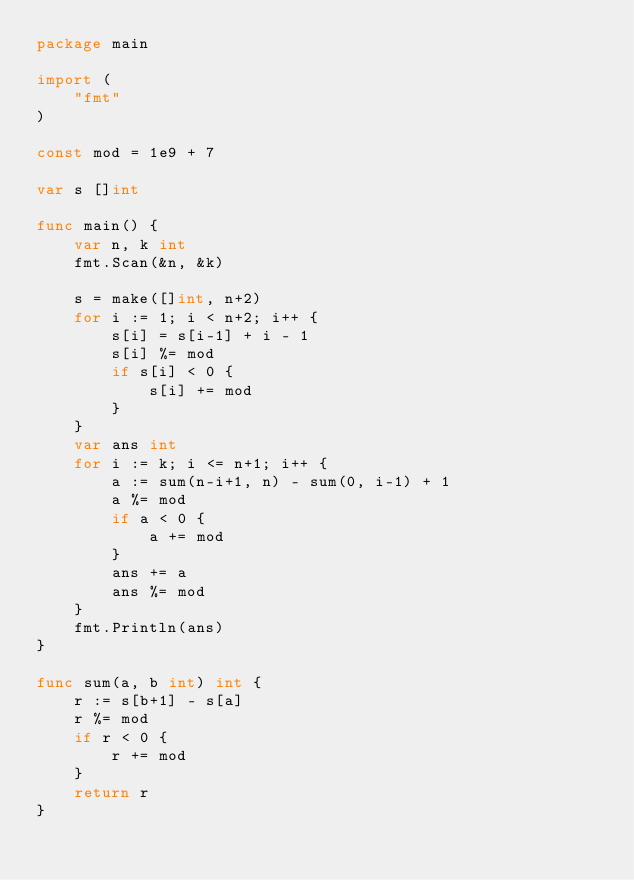<code> <loc_0><loc_0><loc_500><loc_500><_Go_>package main

import (
	"fmt"
)

const mod = 1e9 + 7

var s []int

func main() {
	var n, k int
	fmt.Scan(&n, &k)

	s = make([]int, n+2)
	for i := 1; i < n+2; i++ {
		s[i] = s[i-1] + i - 1
		s[i] %= mod
		if s[i] < 0 {
			s[i] += mod
		}
	}
	var ans int
	for i := k; i <= n+1; i++ {
		a := sum(n-i+1, n) - sum(0, i-1) + 1
		a %= mod
		if a < 0 {
			a += mod
		}
		ans += a
		ans %= mod
	}
	fmt.Println(ans)
}

func sum(a, b int) int {
	r := s[b+1] - s[a]
	r %= mod
	if r < 0 {
		r += mod
	}
	return r
}
</code> 